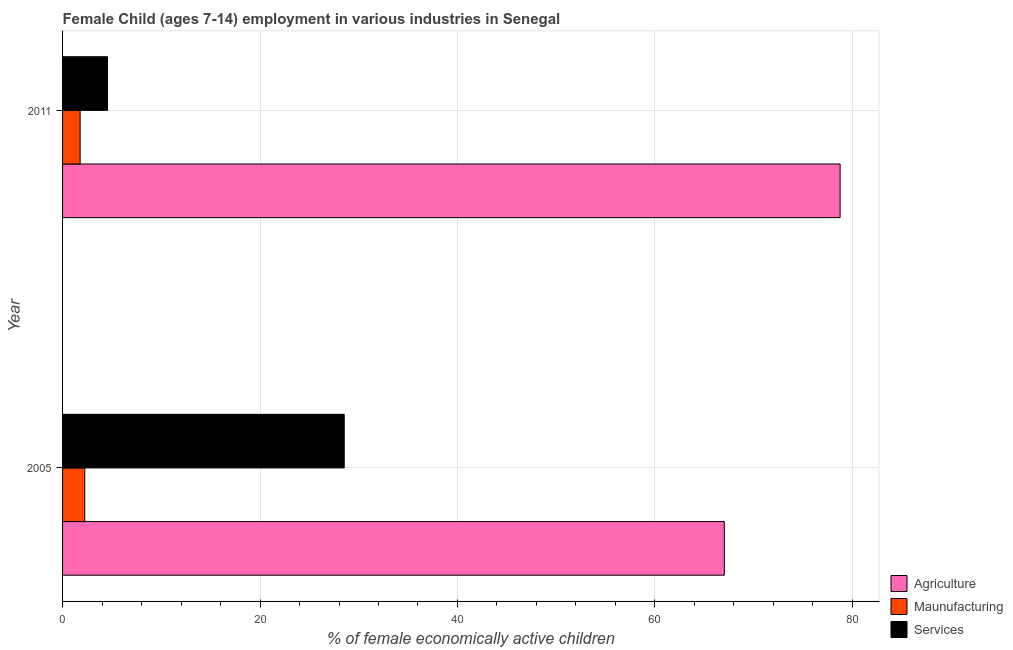Are the number of bars on each tick of the Y-axis equal?
Your response must be concise. Yes. How many bars are there on the 1st tick from the top?
Ensure brevity in your answer.  3. How many bars are there on the 1st tick from the bottom?
Provide a short and direct response. 3. What is the percentage of economically active children in manufacturing in 2005?
Ensure brevity in your answer.  2.25. Across all years, what is the maximum percentage of economically active children in manufacturing?
Give a very brief answer. 2.25. Across all years, what is the minimum percentage of economically active children in manufacturing?
Offer a very short reply. 1.78. In which year was the percentage of economically active children in manufacturing minimum?
Your answer should be very brief. 2011. What is the total percentage of economically active children in agriculture in the graph?
Make the answer very short. 145.79. What is the difference between the percentage of economically active children in services in 2005 and that in 2011?
Your answer should be compact. 23.98. What is the difference between the percentage of economically active children in agriculture in 2005 and the percentage of economically active children in manufacturing in 2011?
Offer a very short reply. 65.25. What is the average percentage of economically active children in manufacturing per year?
Give a very brief answer. 2.02. In the year 2005, what is the difference between the percentage of economically active children in services and percentage of economically active children in manufacturing?
Your answer should be very brief. 26.28. What is the ratio of the percentage of economically active children in services in 2005 to that in 2011?
Keep it short and to the point. 6.27. Is the percentage of economically active children in agriculture in 2005 less than that in 2011?
Offer a terse response. Yes. What does the 3rd bar from the top in 2011 represents?
Keep it short and to the point. Agriculture. What does the 1st bar from the bottom in 2005 represents?
Give a very brief answer. Agriculture. Is it the case that in every year, the sum of the percentage of economically active children in agriculture and percentage of economically active children in manufacturing is greater than the percentage of economically active children in services?
Give a very brief answer. Yes. How many years are there in the graph?
Provide a succinct answer. 2. Are the values on the major ticks of X-axis written in scientific E-notation?
Make the answer very short. No. Does the graph contain any zero values?
Your answer should be very brief. No. Does the graph contain grids?
Keep it short and to the point. Yes. How are the legend labels stacked?
Provide a short and direct response. Vertical. What is the title of the graph?
Offer a very short reply. Female Child (ages 7-14) employment in various industries in Senegal. Does "Industrial Nitrous Oxide" appear as one of the legend labels in the graph?
Give a very brief answer. No. What is the label or title of the X-axis?
Provide a succinct answer. % of female economically active children. What is the label or title of the Y-axis?
Offer a terse response. Year. What is the % of female economically active children in Agriculture in 2005?
Offer a very short reply. 67.03. What is the % of female economically active children in Maunufacturing in 2005?
Your answer should be very brief. 2.25. What is the % of female economically active children in Services in 2005?
Your response must be concise. 28.53. What is the % of female economically active children of Agriculture in 2011?
Your response must be concise. 78.76. What is the % of female economically active children of Maunufacturing in 2011?
Offer a very short reply. 1.78. What is the % of female economically active children in Services in 2011?
Provide a short and direct response. 4.55. Across all years, what is the maximum % of female economically active children of Agriculture?
Your answer should be compact. 78.76. Across all years, what is the maximum % of female economically active children in Maunufacturing?
Give a very brief answer. 2.25. Across all years, what is the maximum % of female economically active children of Services?
Give a very brief answer. 28.53. Across all years, what is the minimum % of female economically active children in Agriculture?
Your answer should be compact. 67.03. Across all years, what is the minimum % of female economically active children of Maunufacturing?
Offer a very short reply. 1.78. Across all years, what is the minimum % of female economically active children of Services?
Ensure brevity in your answer.  4.55. What is the total % of female economically active children in Agriculture in the graph?
Offer a terse response. 145.79. What is the total % of female economically active children in Maunufacturing in the graph?
Offer a terse response. 4.03. What is the total % of female economically active children in Services in the graph?
Provide a short and direct response. 33.08. What is the difference between the % of female economically active children in Agriculture in 2005 and that in 2011?
Give a very brief answer. -11.73. What is the difference between the % of female economically active children in Maunufacturing in 2005 and that in 2011?
Make the answer very short. 0.47. What is the difference between the % of female economically active children in Services in 2005 and that in 2011?
Ensure brevity in your answer.  23.98. What is the difference between the % of female economically active children of Agriculture in 2005 and the % of female economically active children of Maunufacturing in 2011?
Keep it short and to the point. 65.25. What is the difference between the % of female economically active children in Agriculture in 2005 and the % of female economically active children in Services in 2011?
Keep it short and to the point. 62.48. What is the difference between the % of female economically active children of Maunufacturing in 2005 and the % of female economically active children of Services in 2011?
Make the answer very short. -2.3. What is the average % of female economically active children of Agriculture per year?
Offer a very short reply. 72.89. What is the average % of female economically active children in Maunufacturing per year?
Keep it short and to the point. 2.02. What is the average % of female economically active children of Services per year?
Ensure brevity in your answer.  16.54. In the year 2005, what is the difference between the % of female economically active children of Agriculture and % of female economically active children of Maunufacturing?
Your answer should be very brief. 64.78. In the year 2005, what is the difference between the % of female economically active children in Agriculture and % of female economically active children in Services?
Provide a succinct answer. 38.5. In the year 2005, what is the difference between the % of female economically active children in Maunufacturing and % of female economically active children in Services?
Give a very brief answer. -26.28. In the year 2011, what is the difference between the % of female economically active children of Agriculture and % of female economically active children of Maunufacturing?
Offer a terse response. 76.98. In the year 2011, what is the difference between the % of female economically active children of Agriculture and % of female economically active children of Services?
Offer a terse response. 74.21. In the year 2011, what is the difference between the % of female economically active children in Maunufacturing and % of female economically active children in Services?
Offer a very short reply. -2.77. What is the ratio of the % of female economically active children of Agriculture in 2005 to that in 2011?
Offer a terse response. 0.85. What is the ratio of the % of female economically active children in Maunufacturing in 2005 to that in 2011?
Make the answer very short. 1.26. What is the ratio of the % of female economically active children in Services in 2005 to that in 2011?
Offer a terse response. 6.27. What is the difference between the highest and the second highest % of female economically active children of Agriculture?
Keep it short and to the point. 11.73. What is the difference between the highest and the second highest % of female economically active children in Maunufacturing?
Offer a very short reply. 0.47. What is the difference between the highest and the second highest % of female economically active children of Services?
Offer a very short reply. 23.98. What is the difference between the highest and the lowest % of female economically active children of Agriculture?
Ensure brevity in your answer.  11.73. What is the difference between the highest and the lowest % of female economically active children in Maunufacturing?
Provide a short and direct response. 0.47. What is the difference between the highest and the lowest % of female economically active children of Services?
Offer a terse response. 23.98. 